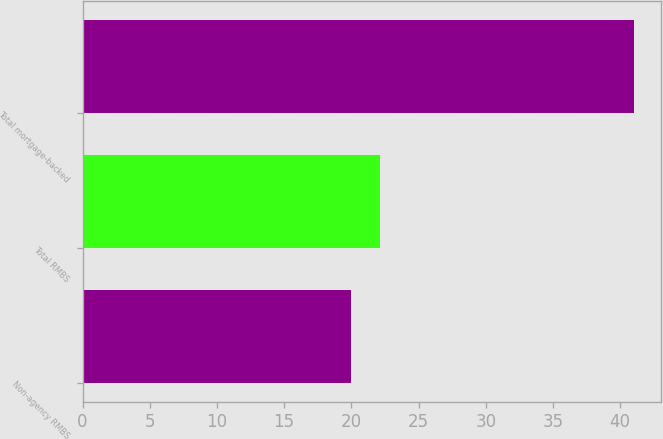<chart> <loc_0><loc_0><loc_500><loc_500><bar_chart><fcel>Non-agency RMBS<fcel>Total RMBS<fcel>Total mortgage-backed<nl><fcel>20<fcel>22.1<fcel>41<nl></chart> 